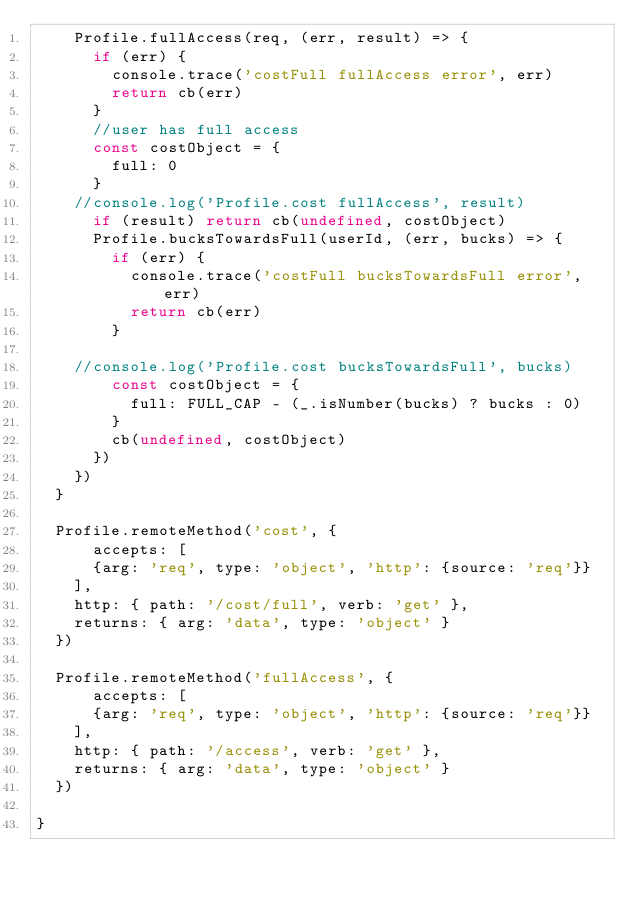Convert code to text. <code><loc_0><loc_0><loc_500><loc_500><_JavaScript_>		Profile.fullAccess(req, (err, result) => {
			if (err) {
				console.trace('costFull fullAccess error', err)
				return cb(err)
			}
			//user has full access
			const costObject = {
				full: 0
			}
		//console.log('Profile.cost fullAccess', result)
			if (result) return cb(undefined, costObject)
			Profile.bucksTowardsFull(userId, (err, bucks) => {
				if (err) {
					console.trace('costFull bucksTowardsFull error', err)
					return cb(err)
				}

		//console.log('Profile.cost bucksTowardsFull', bucks)
				const costObject = {
					full: FULL_CAP - (_.isNumber(bucks) ? bucks : 0)
				}
				cb(undefined, costObject)
			})
		})
	}

	Profile.remoteMethod('cost', {
	    accepts: [
			{arg: 'req', type: 'object', 'http': {source: 'req'}}
		],
		http: { path: '/cost/full', verb: 'get' },
		returns: { arg: 'data', type: 'object' }
	})

	Profile.remoteMethod('fullAccess', {
	    accepts: [
			{arg: 'req', type: 'object', 'http': {source: 'req'}}
		],
		http: { path: '/access', verb: 'get' },
		returns: { arg: 'data', type: 'object' }
	})

}
</code> 